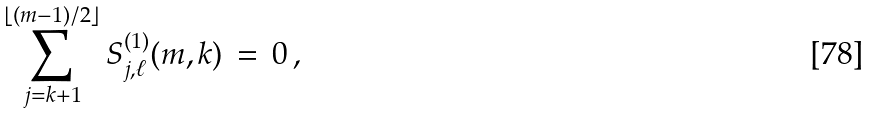<formula> <loc_0><loc_0><loc_500><loc_500>\sum _ { j = k + 1 } ^ { \lfloor ( m - 1 ) / 2 \rfloor } S ^ { ( 1 ) } _ { j , \ell } ( m , k ) \, = \, 0 \, ,</formula> 